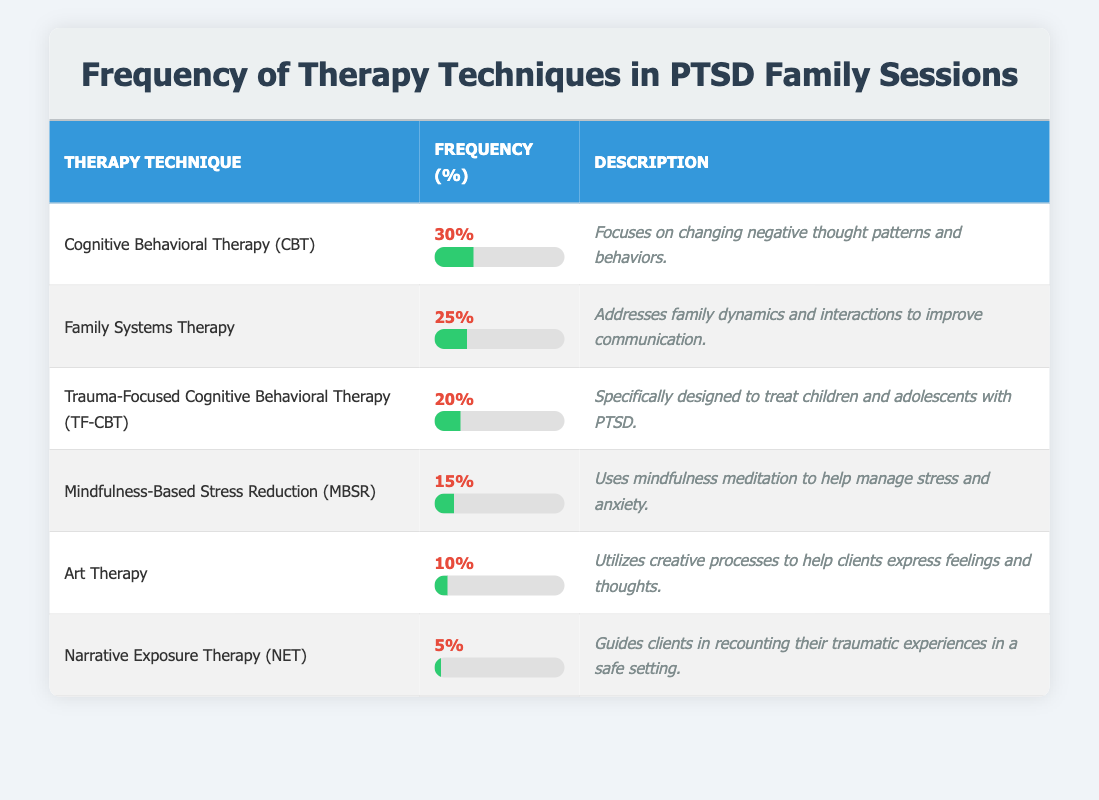What is the frequency of Cognitive Behavioral Therapy (CBT)? The frequency of Cognitive Behavioral Therapy (CBT) is listed in the table. It states that the frequency is 30%.
Answer: 30% Which therapy technique has the lowest frequency? By examining the frequency values in the table, Narrative Exposure Therapy (NET) has the lowest frequency at 5%.
Answer: Narrative Exposure Therapy (NET) What is the combined frequency of Art Therapy and Mindfulness-Based Stress Reduction (MBSR)? The frequency of Art Therapy is 10% and the frequency of Mindfulness-Based Stress Reduction (MBSR) is 15%. Adding these together gives 10% + 15% = 25%.
Answer: 25% Is Family Systems Therapy used more frequently than Narrative Exposure Therapy? The frequency of Family Systems Therapy is 25%, while the frequency of Narrative Exposure Therapy is 5%. Since 25% is greater than 5%, this statement is true.
Answer: Yes What percentage of the therapies focus on children and adolescents? The table shows that only Trauma-Focused Cognitive Behavioral Therapy (TF-CBT) is specifically designed for children and adolescents, which has a frequency of 20%. Since this is the only therapy mentioned, the percentage is 20%.
Answer: 20% What is the average frequency of the listed therapy techniques? To find the average, sum the frequencies: 30 + 25 + 20 + 15 + 10 + 5 = 105. Then divide by the number of techniques, which is 6. So, 105/6 = 17.5%.
Answer: 17.5% Which techniques are used more than 15% of the time? Looking at the frequency values, Cognitive Behavioral Therapy (30%), Family Systems Therapy (25%), and Trauma-Focused Cognitive Behavioral Therapy (20%) are all above 15%. This indicates three techniques.
Answer: 3 techniques How does the frequency of Trauma-Focused Cognitive Behavioral Therapy (TF-CBT) compare to the average frequency of therapy techniques? The frequency of TF-CBT is 20%. As calculated before, the average frequency is 17.5%. Since 20% is greater than the average of 17.5%, the comparison shows TF-CBT is above average.
Answer: Above average 